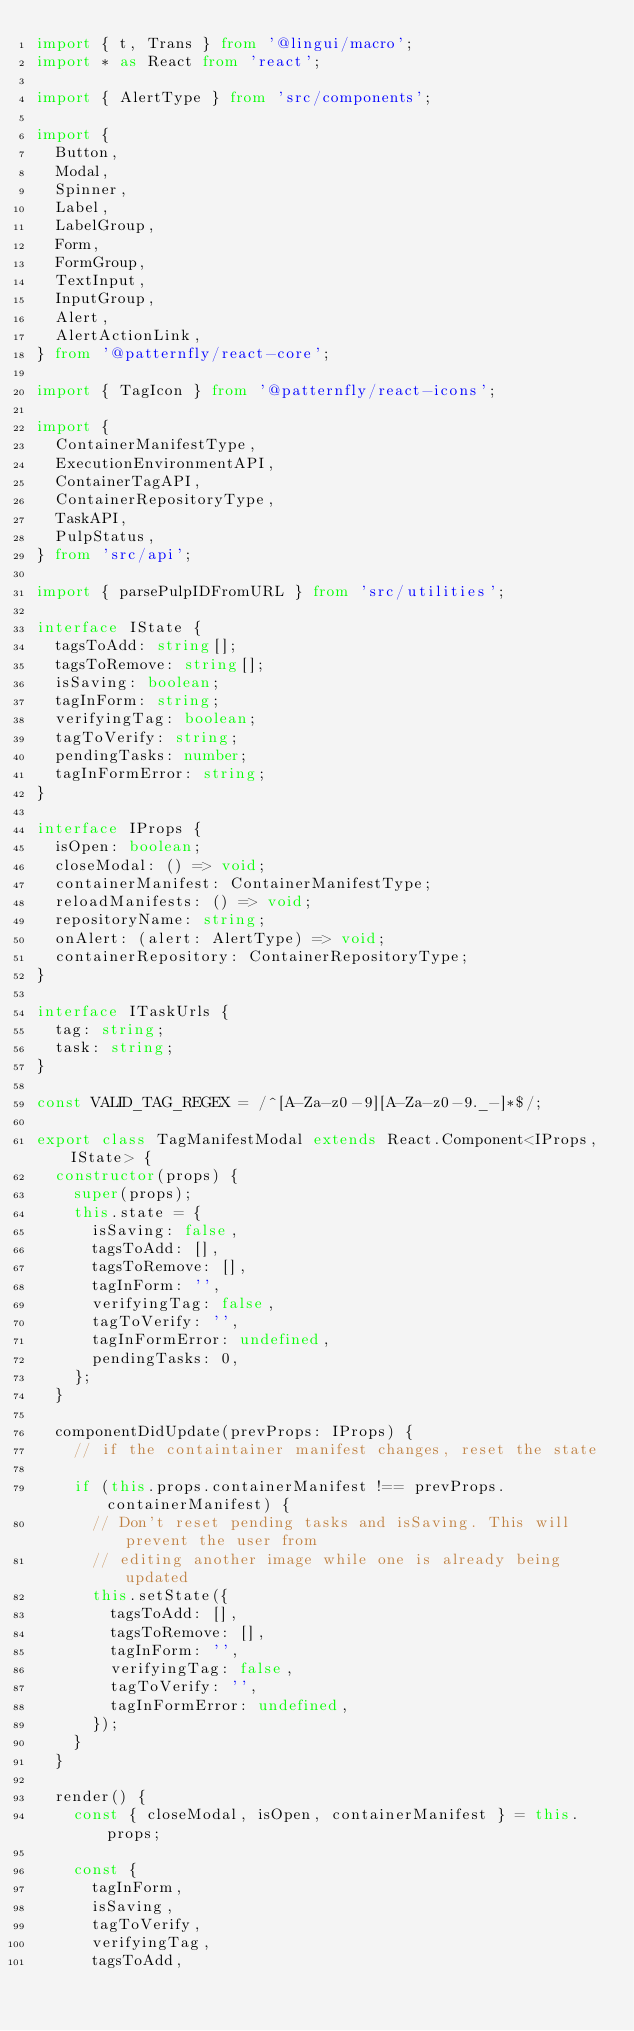Convert code to text. <code><loc_0><loc_0><loc_500><loc_500><_TypeScript_>import { t, Trans } from '@lingui/macro';
import * as React from 'react';

import { AlertType } from 'src/components';

import {
  Button,
  Modal,
  Spinner,
  Label,
  LabelGroup,
  Form,
  FormGroup,
  TextInput,
  InputGroup,
  Alert,
  AlertActionLink,
} from '@patternfly/react-core';

import { TagIcon } from '@patternfly/react-icons';

import {
  ContainerManifestType,
  ExecutionEnvironmentAPI,
  ContainerTagAPI,
  ContainerRepositoryType,
  TaskAPI,
  PulpStatus,
} from 'src/api';

import { parsePulpIDFromURL } from 'src/utilities';

interface IState {
  tagsToAdd: string[];
  tagsToRemove: string[];
  isSaving: boolean;
  tagInForm: string;
  verifyingTag: boolean;
  tagToVerify: string;
  pendingTasks: number;
  tagInFormError: string;
}

interface IProps {
  isOpen: boolean;
  closeModal: () => void;
  containerManifest: ContainerManifestType;
  reloadManifests: () => void;
  repositoryName: string;
  onAlert: (alert: AlertType) => void;
  containerRepository: ContainerRepositoryType;
}

interface ITaskUrls {
  tag: string;
  task: string;
}

const VALID_TAG_REGEX = /^[A-Za-z0-9][A-Za-z0-9._-]*$/;

export class TagManifestModal extends React.Component<IProps, IState> {
  constructor(props) {
    super(props);
    this.state = {
      isSaving: false,
      tagsToAdd: [],
      tagsToRemove: [],
      tagInForm: '',
      verifyingTag: false,
      tagToVerify: '',
      tagInFormError: undefined,
      pendingTasks: 0,
    };
  }

  componentDidUpdate(prevProps: IProps) {
    // if the containtainer manifest changes, reset the state

    if (this.props.containerManifest !== prevProps.containerManifest) {
      // Don't reset pending tasks and isSaving. This will prevent the user from
      // editing another image while one is already being updated
      this.setState({
        tagsToAdd: [],
        tagsToRemove: [],
        tagInForm: '',
        verifyingTag: false,
        tagToVerify: '',
        tagInFormError: undefined,
      });
    }
  }

  render() {
    const { closeModal, isOpen, containerManifest } = this.props;

    const {
      tagInForm,
      isSaving,
      tagToVerify,
      verifyingTag,
      tagsToAdd,</code> 